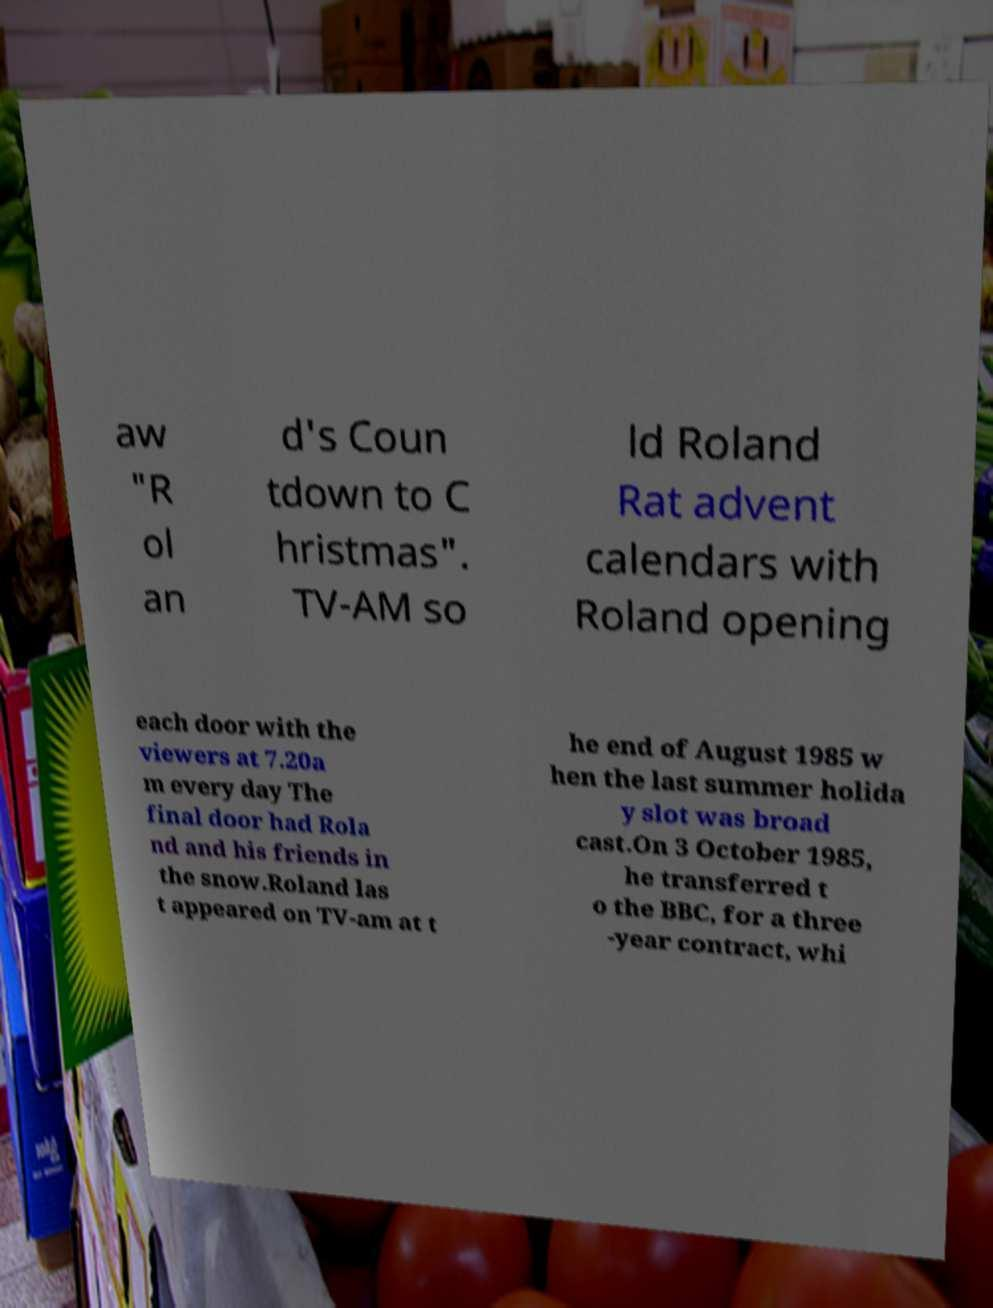Please identify and transcribe the text found in this image. aw "R ol an d's Coun tdown to C hristmas". TV-AM so ld Roland Rat advent calendars with Roland opening each door with the viewers at 7.20a m every day The final door had Rola nd and his friends in the snow.Roland las t appeared on TV-am at t he end of August 1985 w hen the last summer holida y slot was broad cast.On 3 October 1985, he transferred t o the BBC, for a three -year contract, whi 